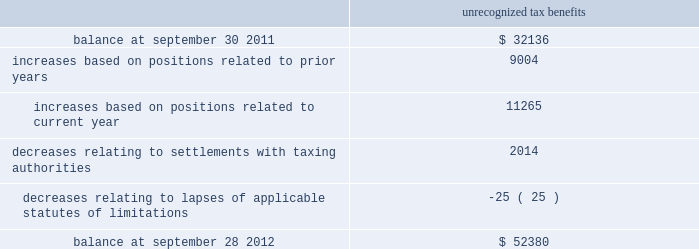Skyworks solutions , inc .
Notes to consolidated financial statements 2014 ( continued ) maintained a valuation allowance of $ 47.0 million .
This valuation allowance is comprised of $ 33.6 million related to u.s .
State tax credits , of which $ 3.6 million are state tax credits acquired from aati in fiscal year 2012 , and $ 13.4 million related to foreign deferred tax assets .
If these benefits are recognized in a future period the valuation allowance on deferred tax assets will be reversed and up to a $ 46.6 million income tax benefit , and up to a $ 0.4 million reduction to goodwill may be recognized .
The company will need to generate $ 209.0 million of future united states federal taxable income to utilize our united states deferred tax assets as of september 28 , 2012 .
Deferred tax assets are recognized for foreign operations when management believes it is more likely than not that the deferred tax assets will be recovered during the carry forward period .
The company will continue to assess its valuation allowance in future periods .
As of september 28 , 2012 , the company has united states federal net operating loss carry forwards of approximately $ 74.3 million , including $ 29.5 million related to the acquisition of sige , which will expire at various dates through 2030 and $ 28.1 million related to the acquisition of aati , which will expire at various dates through 2031 .
The utilization of these net operating losses is subject to certain annual limitations as required under internal revenue code section 382 and similar state income tax provisions .
The company also has united states federal income tax credit carry forwards of $ 37.8 million , of which $ 30.4 million of federal income tax credit carry forwards have not been recorded as a deferred tax asset .
The company also has state income tax credit carry forwards of $ 33.6 million , for which the company has provided a valuation allowance .
The united states federal tax credits expire at various dates through 2032 .
The state tax credits relate primarily to california research tax credits which can be carried forward indefinitely .
The company has continued to expand its operations and increase its investments in numerous international jurisdictions .
These activities will increase the company 2019s earnings attributable to foreign jurisdictions .
As of september 28 , 2012 , no provision has been made for united states federal , state , or additional foreign income taxes related to approximately $ 371.5 million of undistributed earnings of foreign subsidiaries which have been or are intended to be permanently reinvested .
It is not practicable to determine the united states federal income tax liability , if any , which would be payable if such earnings were not permanently reinvested .
The company 2019s gross unrecognized tax benefits totaled $ 52.4 million and $ 32.1 million as of september 28 , 2012 and september 30 , 2011 , respectively .
Of the total unrecognized tax benefits at september 28 , 2012 , $ 38.8 million would impact the effective tax rate , if recognized .
The remaining unrecognized tax benefits would not impact the effective tax rate , if recognized , due to the company 2019s valuation allowance and certain positions which were required to be capitalized .
There are no positions which the company anticipates could change within the next twelve months .
A reconciliation of the beginning and ending amount of gross unrecognized tax benefits is as follows ( in thousands ) : unrecognized tax benefits .
Page 114 annual report .
In 2012 what was the percentage change in the gross unrecognized tax benefits? 
Computations: ((52380 - 32136) / 32136)
Answer: 0.62995. 